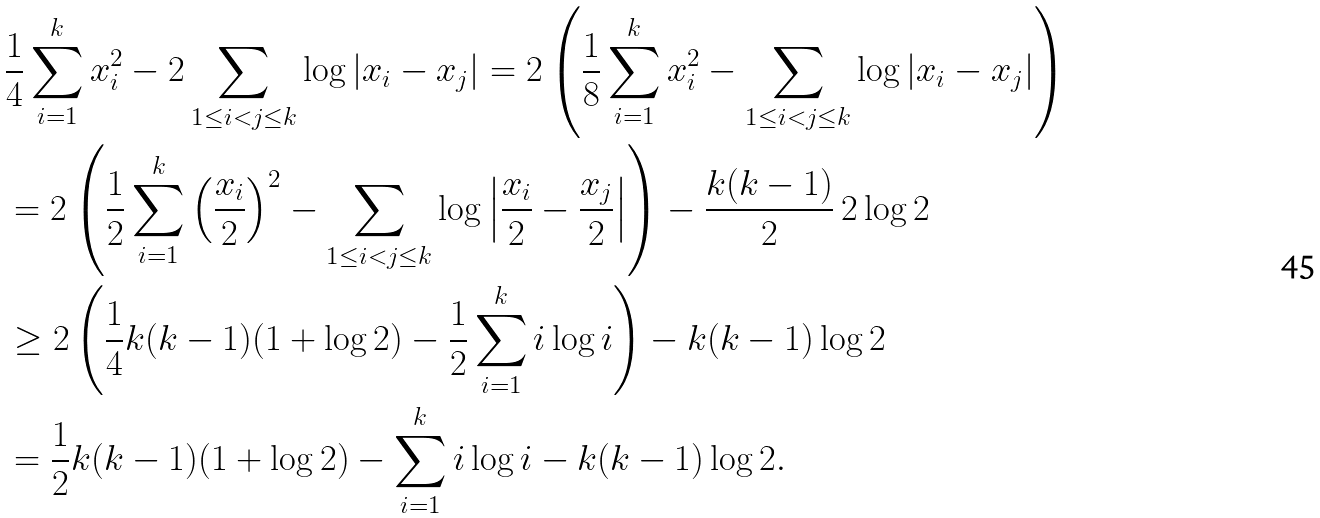<formula> <loc_0><loc_0><loc_500><loc_500>& \frac { 1 } { 4 } \sum _ { i = 1 } ^ { k } x _ { i } ^ { 2 } - 2 \sum _ { 1 \leq i < j \leq k } \log | x _ { i } - x _ { j } | = 2 \left ( \frac { 1 } { 8 } \sum _ { i = 1 } ^ { k } x _ { i } ^ { 2 } - \sum _ { 1 \leq i < j \leq k } \log | x _ { i } - x _ { j } | \right ) \\ & = 2 \left ( \frac { 1 } { 2 } \sum _ { i = 1 } ^ { k } \left ( \frac { x _ { i } } { 2 } \right ) ^ { 2 } - \sum _ { 1 \leq i < j \leq k } \log \left | \frac { x _ { i } } { 2 } - \frac { x _ { j } } { 2 } \right | \right ) - \frac { k ( k - 1 ) } { 2 } \, 2 \log 2 \\ & \geq 2 \left ( \frac { 1 } { 4 } k ( k - 1 ) ( 1 + \log 2 ) - \frac { 1 } { 2 } \sum _ { i = 1 } ^ { k } i \log i \right ) - k ( k - 1 ) \log 2 \\ & = \frac { 1 } { 2 } k ( k - 1 ) ( 1 + \log 2 ) - \sum _ { i = 1 } ^ { k } i \log i - k ( k - 1 ) \log 2 .</formula> 